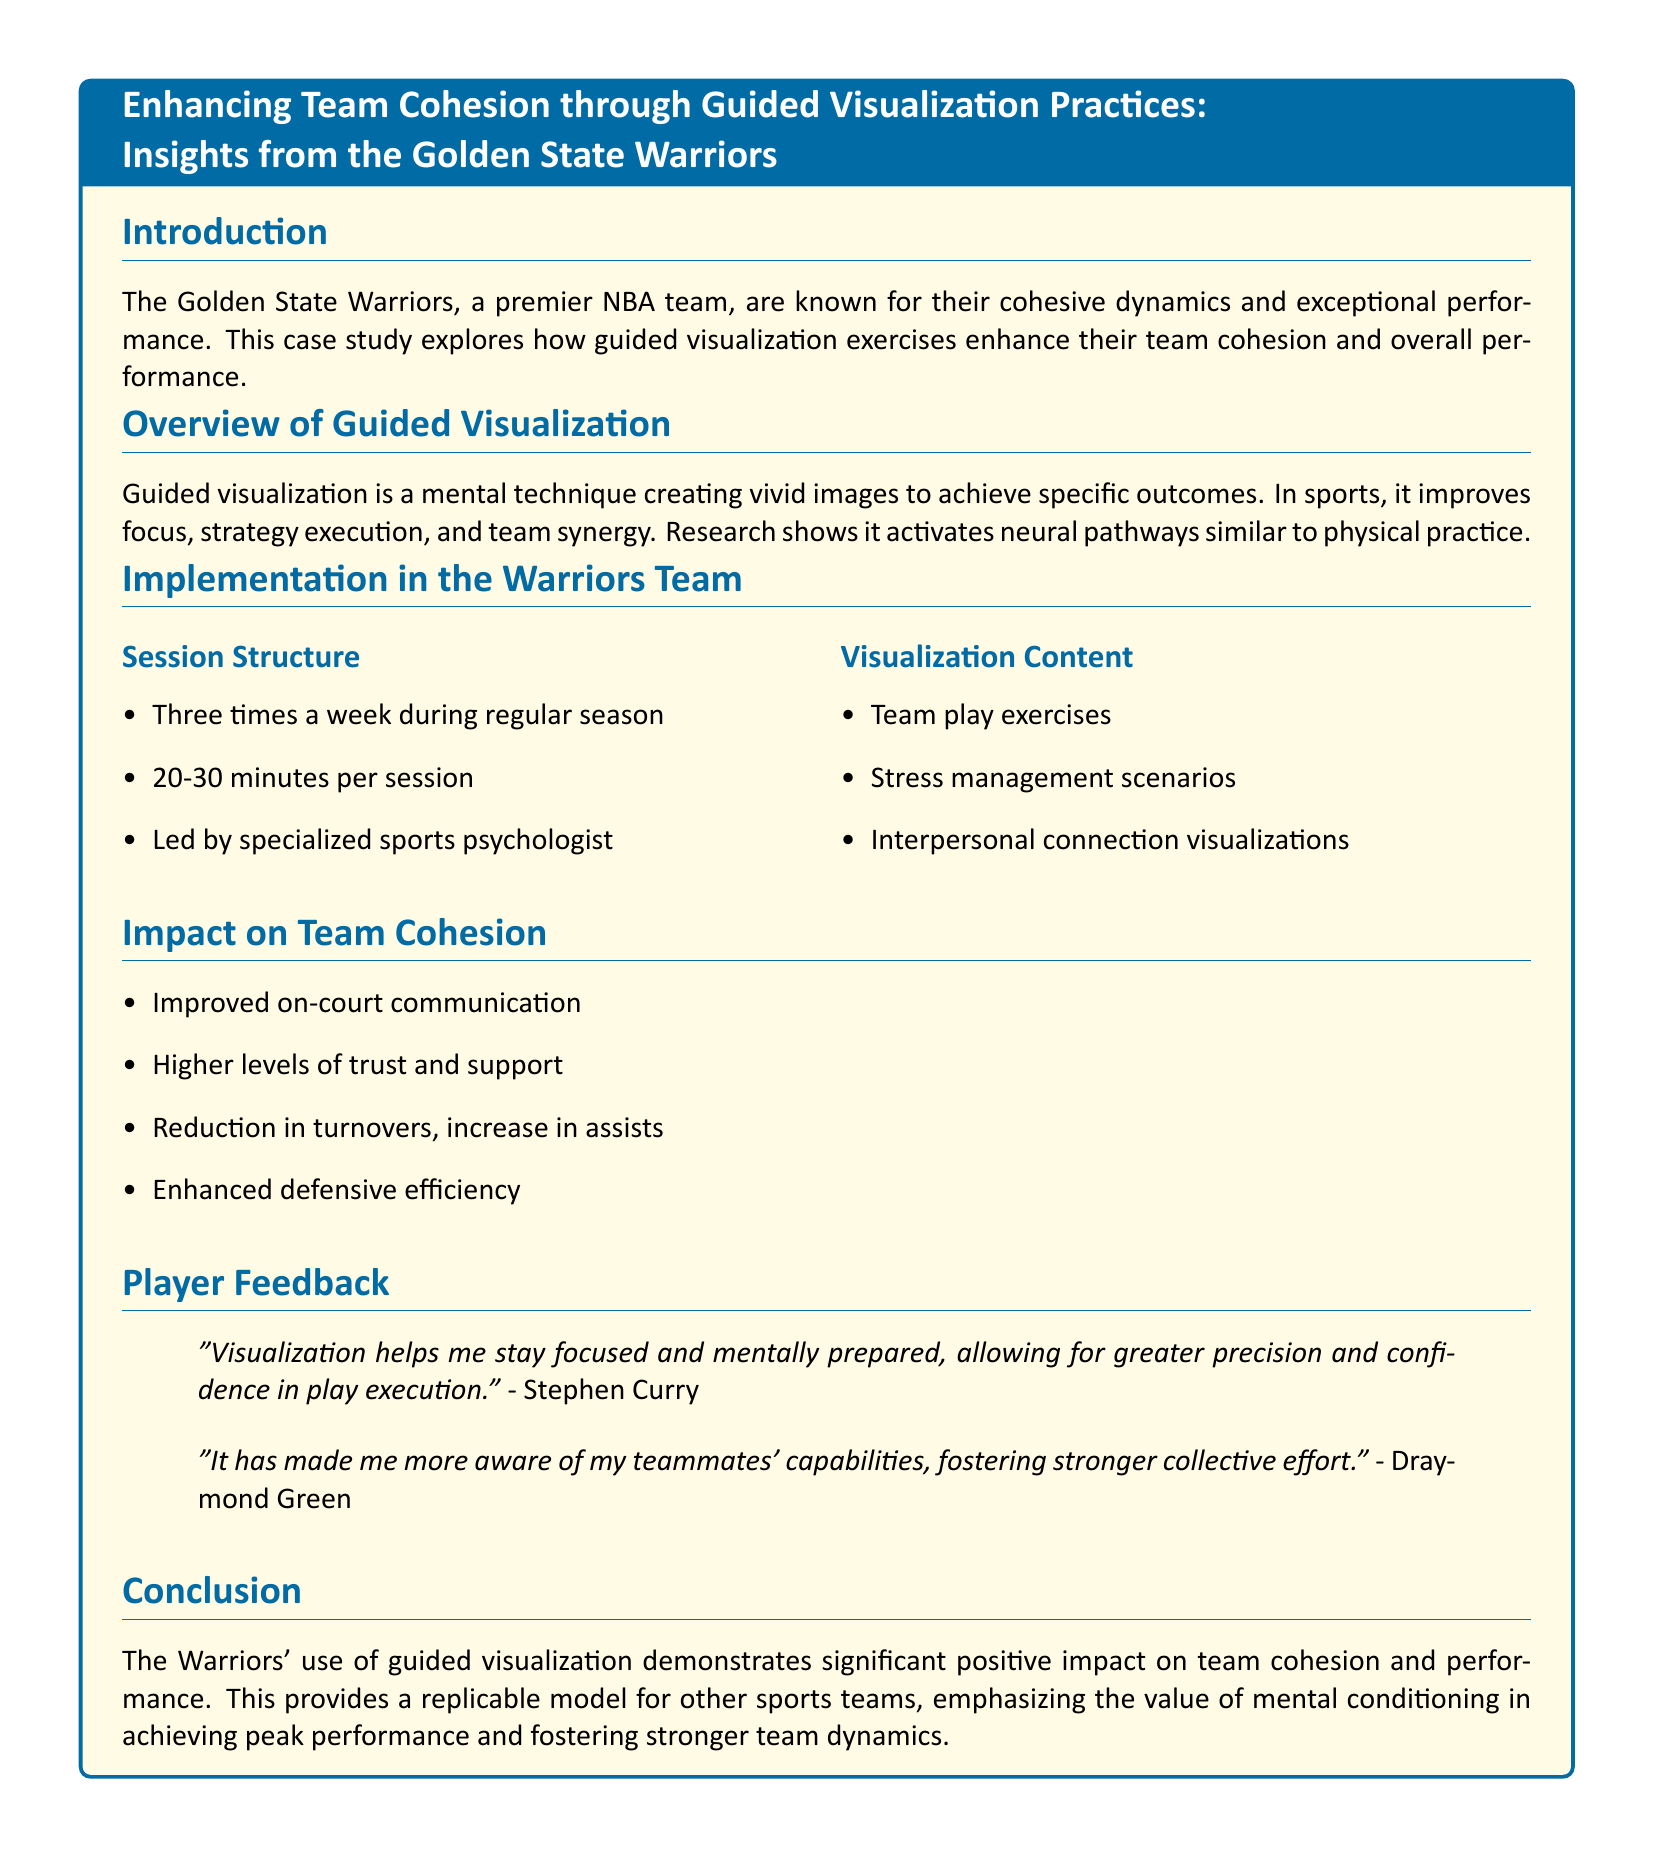what is the name of the NBA team discussed in the case study? The case study discusses the Golden State Warriors as the premier NBA team.
Answer: Golden State Warriors how often does the visualization session occur during the regular season? The document states that the visualization sessions are held three times a week during the regular season.
Answer: three times a week who leads the visualization sessions for the Warriors? According to the case study, the sessions are led by a specialized sports psychologist.
Answer: specialized sports psychologist what is the duration of each visualization session? The document specifies that each session lasts 20-30 minutes.
Answer: 20-30 minutes what is one specific outcome of the guided visualization exercises mentioned? One of the impacts outlined is improved on-court communication among players.
Answer: improved on-court communication which player stated that visualization helps them stay focused? The player who mentioned that visualization helps them stay focused is Stephen Curry.
Answer: Stephen Curry what type of content is included in the visualization exercises? The visualization exercises include team play exercises, stress management scenarios, and interpersonal connection visualizations.
Answer: team play exercises, stress management scenarios, interpersonal connection visualizations how does guided visualization affect team trust? The document indicates that guided visualization leads to higher levels of trust and support within the team.
Answer: higher levels of trust and support what is the overall conclusion about the use of guided visualization? The conclusion highlights that the Warriors' use of guided visualization has a significant positive impact on team cohesion and performance.
Answer: significant positive impact on team cohesion and performance 